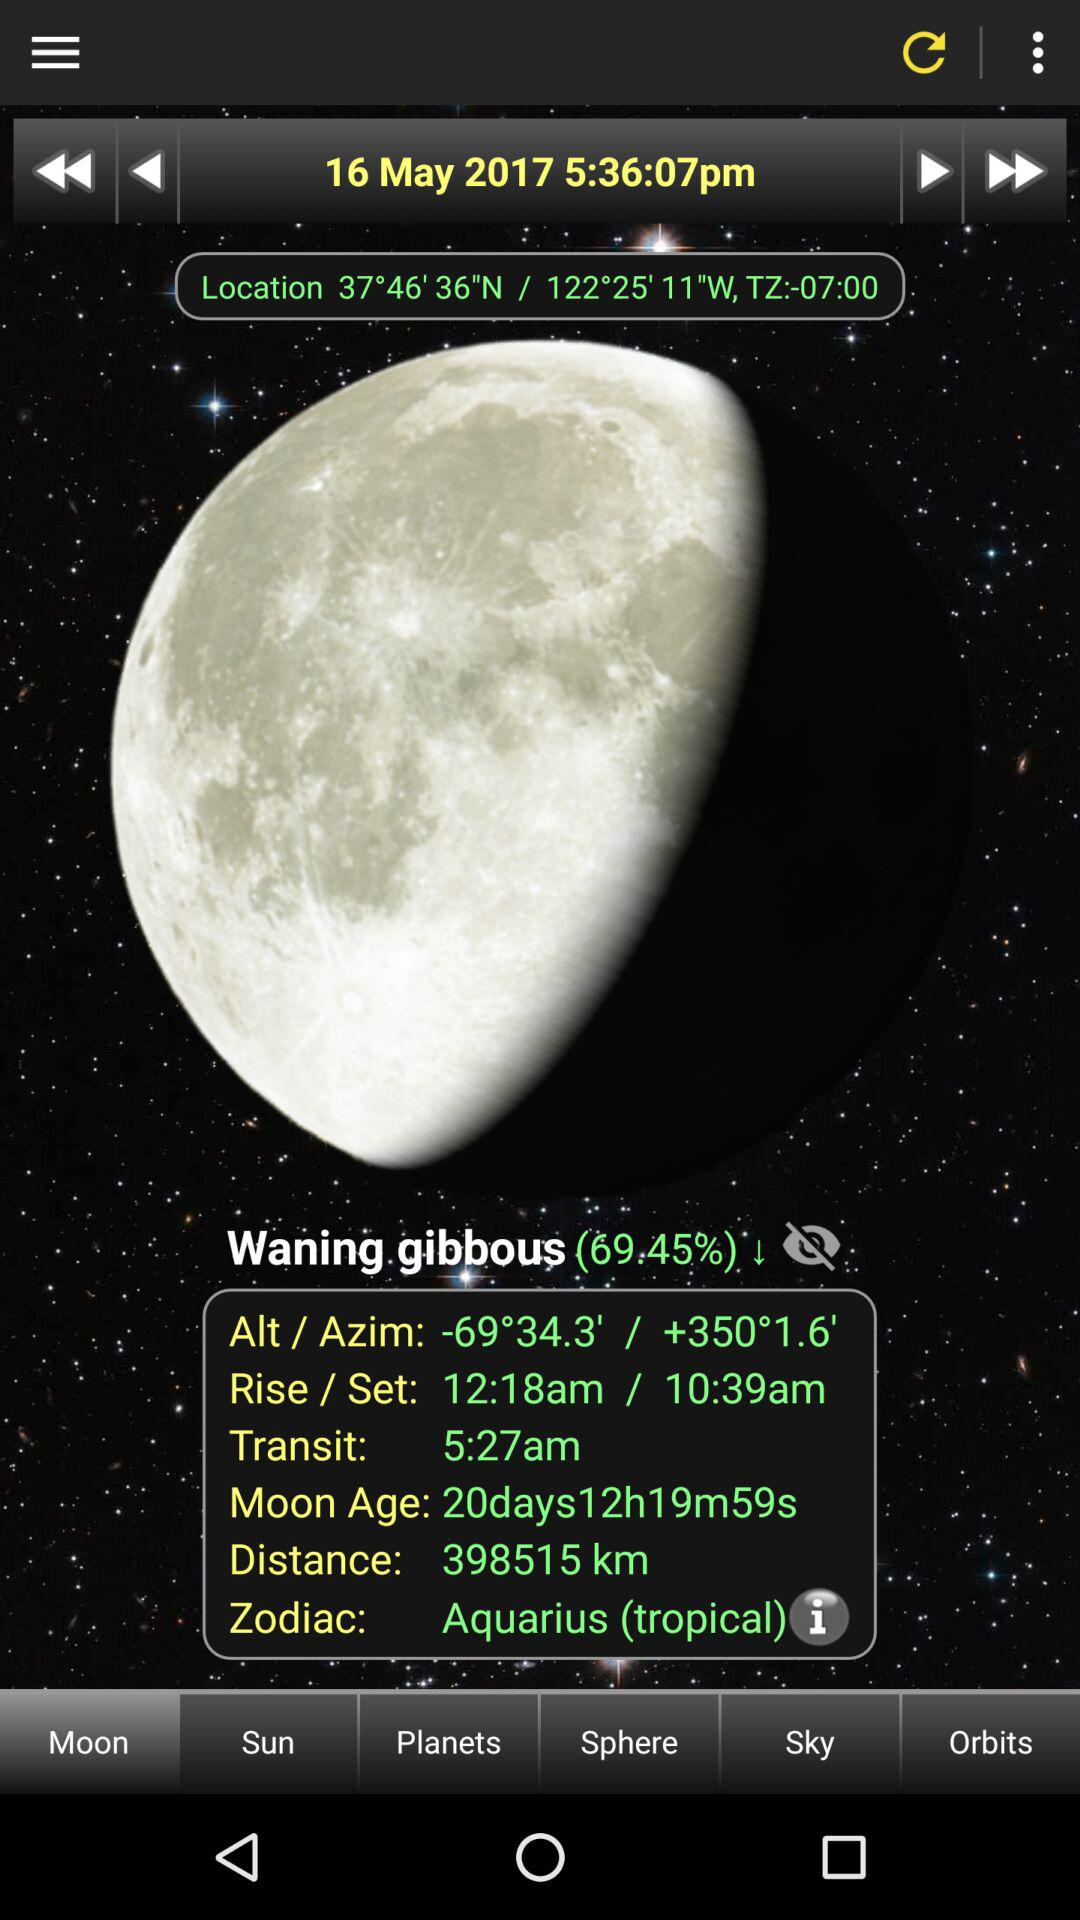What is the distance? The distance is 398515 km. 